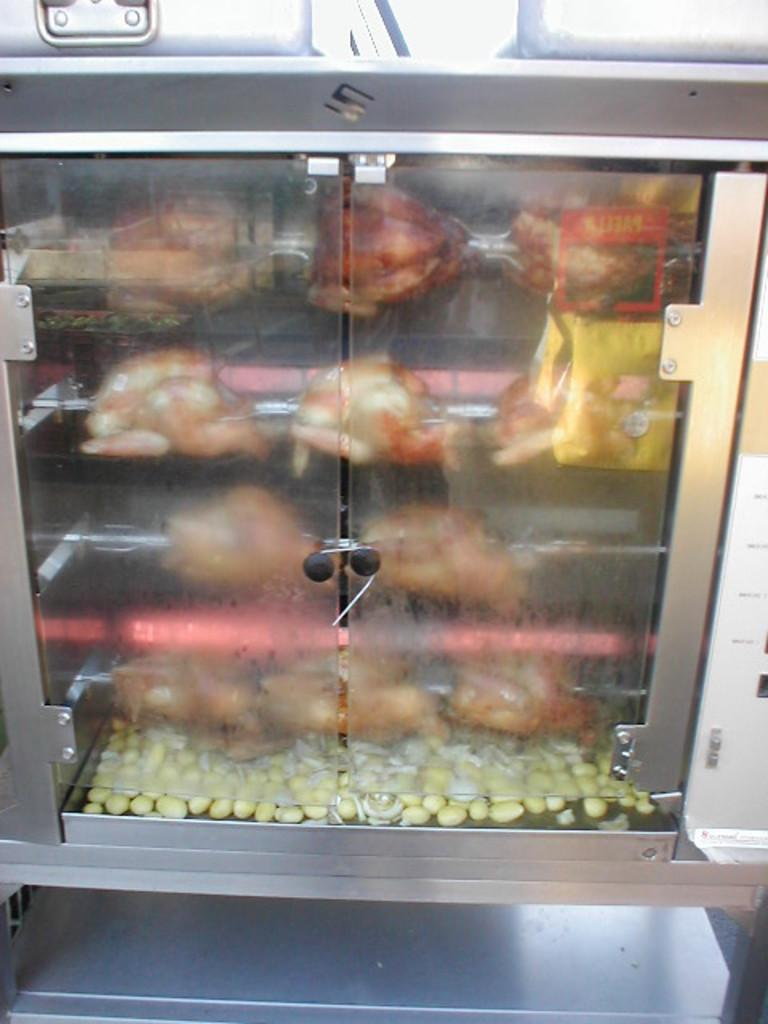What is the main object in the center of the image? There is a cabinet in the center of the image. What is inside the cabinet? The cabinet contains many food items. Are there any other objects visible in the image besides the cabinet? Yes, there are other objects visible in the image. What channel is the robin watching on the fifth shelf of the cabinet? There is no robin or television present in the image, and therefore no channel to watch. 